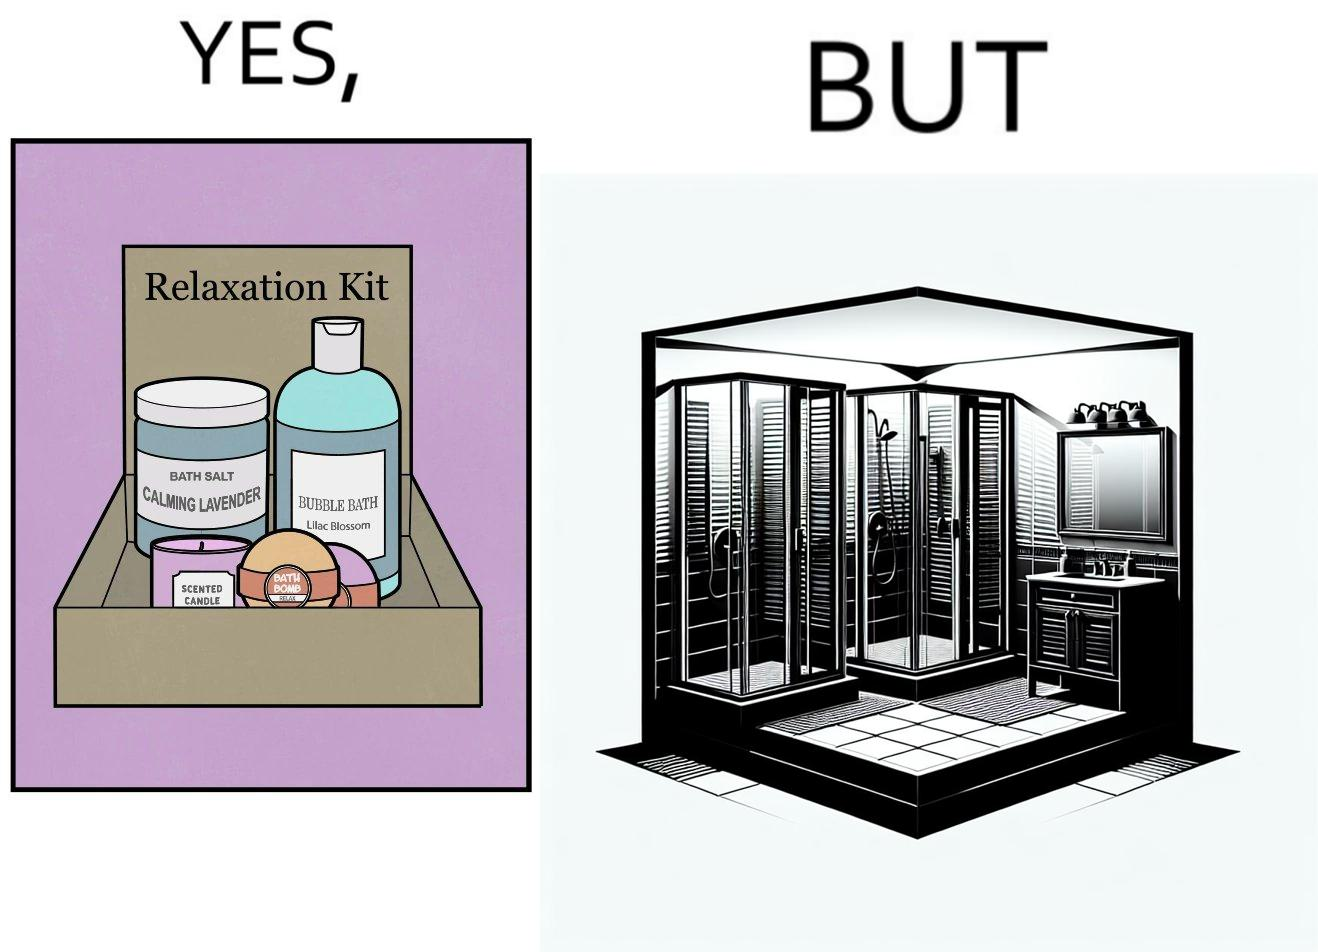Describe the contrast between the left and right parts of this image. In the left part of the image: a relaxation kit, with several products intended to bring calm and peace to the person using the kit. In the right part of the image: a showering area with doors. 